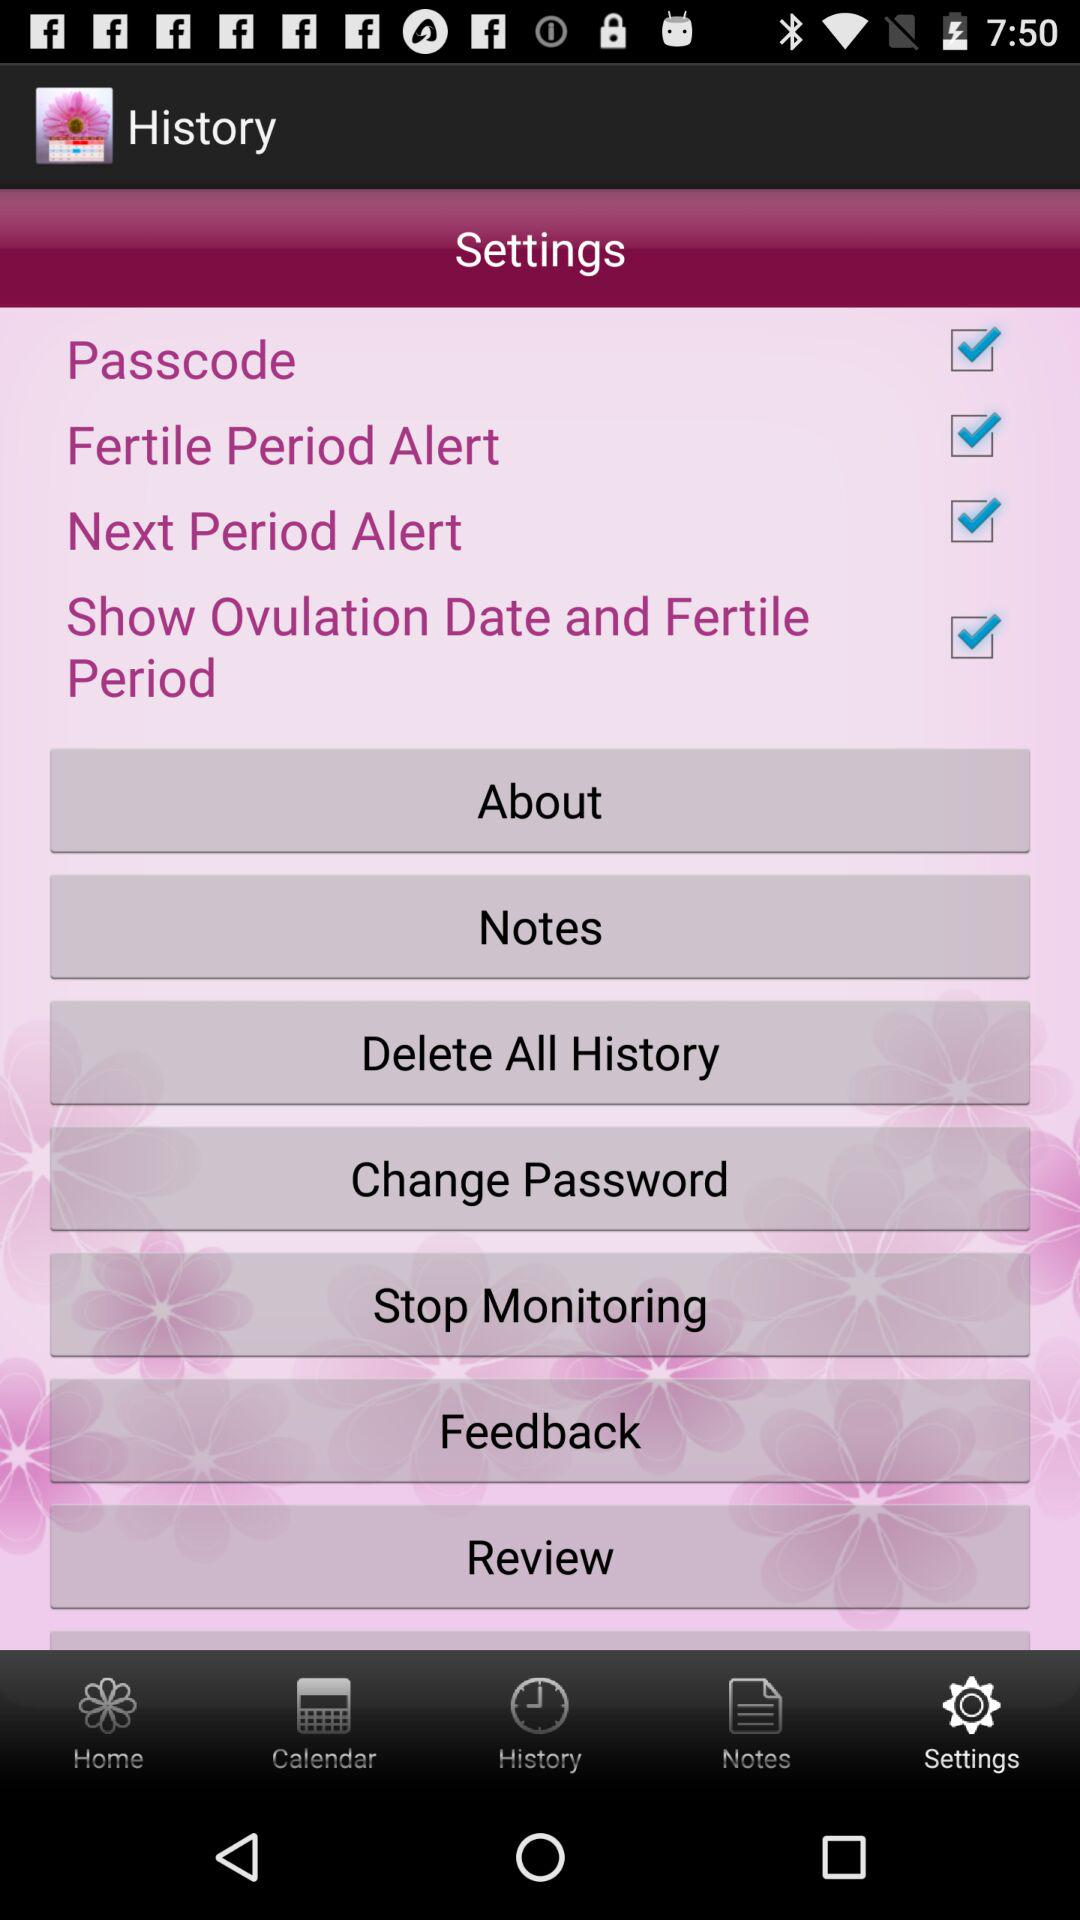What is the status of the next period alert? The status is on. 